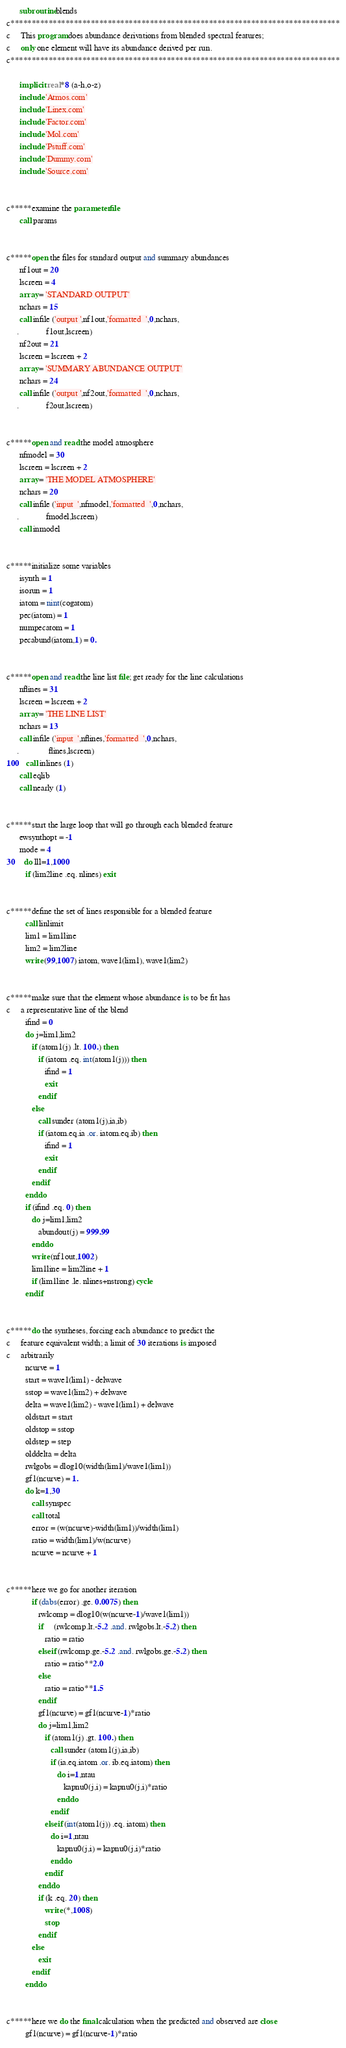<code> <loc_0><loc_0><loc_500><loc_500><_FORTRAN_>
      subroutine blends
c******************************************************************************
c     This program does abundance derivations from blended spectral features;
c     only one element will have its abundance derived per run.
c******************************************************************************

      implicit real*8 (a-h,o-z)
      include 'Atmos.com'
      include 'Linex.com'
      include 'Factor.com'
      include 'Mol.com'
      include 'Pstuff.com'
      include 'Dummy.com'
      include 'Source.com'
      

c*****examine the parameter file
      call params


c*****open the files for standard output and summary abundances
      nf1out = 20
      lscreen = 4
      array = 'STANDARD OUTPUT'
      nchars = 15
      call infile ('output ',nf1out,'formatted  ',0,nchars,
     .             f1out,lscreen)
      nf2out = 21
      lscreen = lscreen + 2
      array = 'SUMMARY ABUNDANCE OUTPUT'
      nchars = 24
      call infile ('output ',nf2out,'formatted  ',0,nchars,
     .             f2out,lscreen)


c*****open and read the model atmosphere
      nfmodel = 30
      lscreen = lscreen + 2
      array = 'THE MODEL ATMOSPHERE'
      nchars = 20
      call infile ('input  ',nfmodel,'formatted  ',0,nchars,
     .             fmodel,lscreen)
      call inmodel


c*****initialize some variables
      isynth = 1
      isorun = 1
      iatom = nint(cogatom)
      pec(iatom) = 1
      numpecatom = 1
      pecabund(iatom,1) = 0.


c*****open and read the line list file; get ready for the line calculations
      nflines = 31
      lscreen = lscreen + 2
      array = 'THE LINE LIST'
      nchars = 13
      call infile ('input  ',nflines,'formatted  ',0,nchars,
     .              flines,lscreen)
100   call inlines (1)
      call eqlib
      call nearly (1)


c*****start the large loop that will go through each blended feature
      ewsynthopt = -1
      mode = 4
30    do lll=1,1000
         if (lim2line .eq. nlines) exit


c*****define the set of lines responsible for a blended feature
         call linlimit
         lim1 = lim1line
         lim2 = lim2line
         write (99,1007) iatom, wave1(lim1), wave1(lim2)


c*****make sure that the element whose abundance is to be fit has
c     a representative line of the blend
         ifind = 0
         do j=lim1,lim2
            if (atom1(j) .lt. 100.) then
               if (iatom .eq. int(atom1(j))) then
                  ifind = 1
                  exit
               endif
            else
               call sunder (atom1(j),ia,ib)
               if (iatom.eq.ia .or. iatom.eq.ib) then
                  ifind = 1
                  exit
               endif
            endif
         enddo
         if (ifind .eq. 0) then
            do j=lim1,lim2
               abundout(j) = 999.99
            enddo
            write (nf1out,1002)
            lim1line = lim2line + 1
            if (lim1line .le. nlines+nstrong) cycle
         endif
 

c*****do the syntheses, forcing each abundance to predict the
c     feature equivalent width; a limit of 30 iterations is imposed
c     arbitrarily
         ncurve = 1
         start = wave1(lim1) - delwave
         sstop = wave1(lim2) + delwave
         delta = wave1(lim2) - wave1(lim1) + delwave
         oldstart = start
         oldstop = sstop
         oldstep = step
         olddelta = delta
         rwlgobs = dlog10(width(lim1)/wave1(lim1))
         gf1(ncurve) = 1.
         do k=1,30
            call synspec
            call total
            error = (w(ncurve)-width(lim1))/width(lim1)
            ratio = width(lim1)/w(ncurve)
            ncurve = ncurve + 1


c*****here we go for another iteration
            if (dabs(error) .ge. 0.0075) then
               rwlcomp = dlog10(w(ncurve-1)/wave1(lim1))
               if     (rwlcomp.lt.-5.2 .and. rwlgobs.lt.-5.2) then 
                  ratio = ratio
               elseif (rwlcomp.ge.-5.2 .and. rwlgobs.ge.-5.2) then 
                  ratio = ratio**2.0
               else   
                  ratio = ratio**1.5
               endif
               gf1(ncurve) = gf1(ncurve-1)*ratio
               do j=lim1,lim2
                  if (atom1(j) .gt. 100.) then
                     call sunder (atom1(j),ia,ib)
                     if (ia.eq.iatom .or. ib.eq.iatom) then
                        do i=1,ntau                                
                           kapnu0(j,i) = kapnu0(j,i)*ratio            
                        enddo
                     endif
                  elseif (int(atom1(j)) .eq. iatom) then
                     do i=1,ntau                                
                        kapnu0(j,i) = kapnu0(j,i)*ratio            
                     enddo
                  endif
               enddo
               if (k .eq. 20) then
                  write (*,1008)
                  stop
               endif
            else
               exit
            endif
         enddo


c*****here we do the final calculation when the predicted and observed are close
         gf1(ncurve) = gf1(ncurve-1)*ratio</code> 